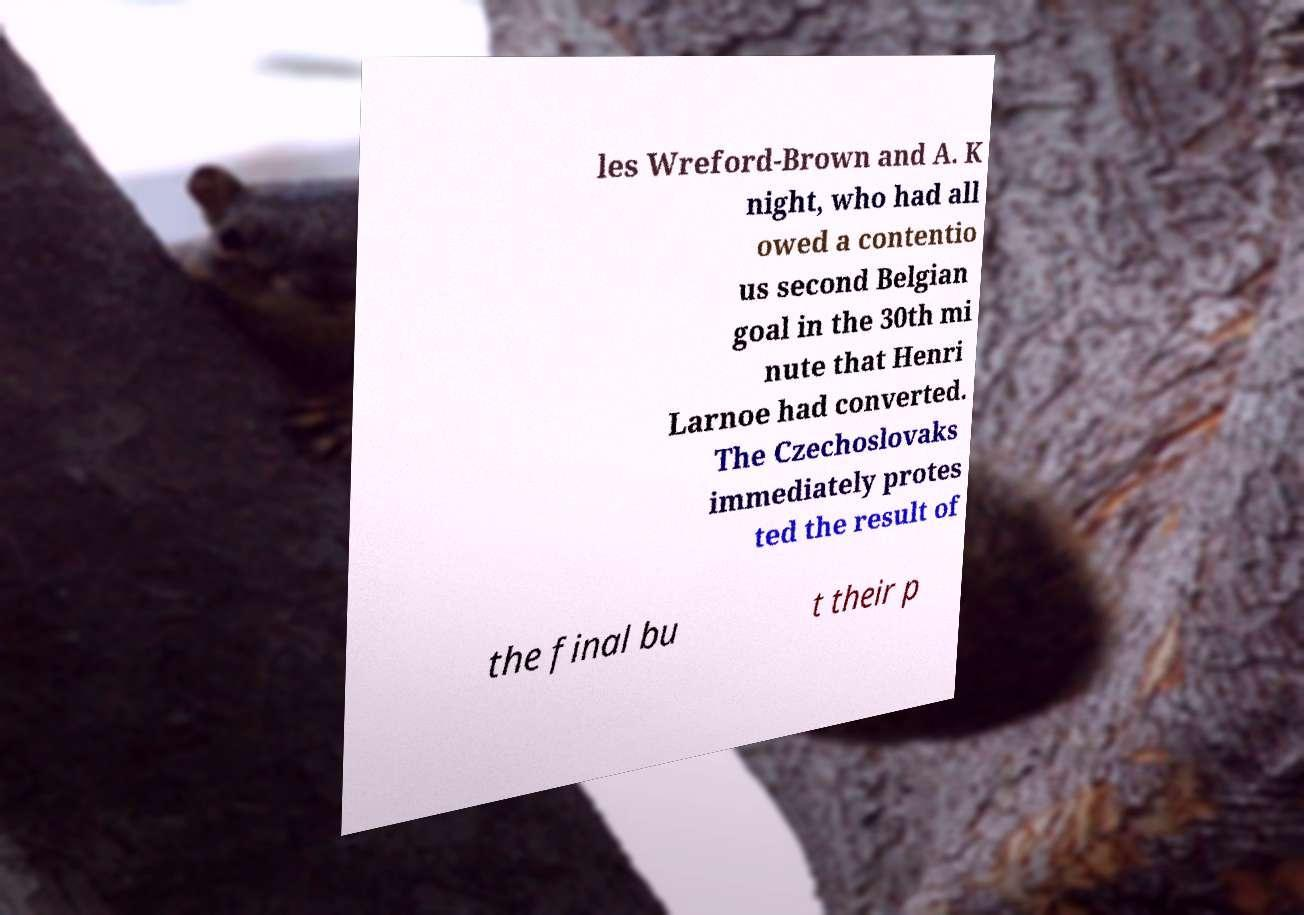Can you read and provide the text displayed in the image?This photo seems to have some interesting text. Can you extract and type it out for me? les Wreford-Brown and A. K night, who had all owed a contentio us second Belgian goal in the 30th mi nute that Henri Larnoe had converted. The Czechoslovaks immediately protes ted the result of the final bu t their p 